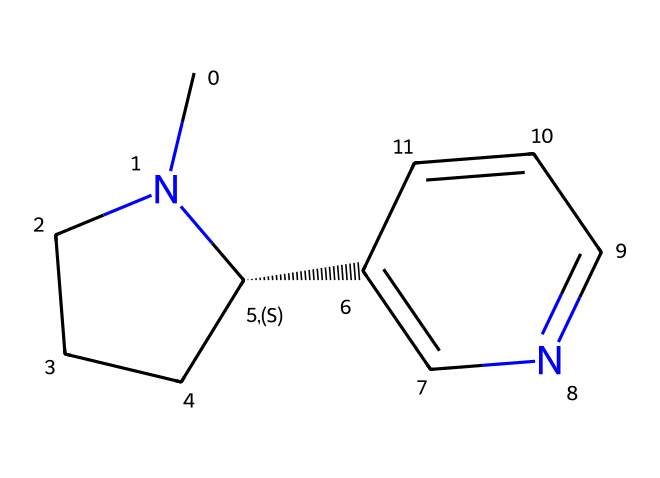What is the molecular formula of this chemical? By analyzing the structure represented by the SMILES notation, we can count the number of carbon (C), hydrogen (H), and nitrogen (N) atoms. The chemical has 10 carbon atoms, 14 hydrogen atoms, and 2 nitrogen atoms, resulting in a molecular formula of C10H14N2.
Answer: C10H14N2 How many rings are present in the structure? Observing the SMILES representation, we can identify two ring structures. One is a piperidine ring (six-membered) and the other is a pyridine ring (five-membered). Thus, there are 2 rings overall in the chemical structure.
Answer: 2 What is the primary functional group in this chemical? In this structure, the functional groups can often be identified by specific atom arrangements. The presence of nitrogen atoms indicates that it is an amine. Since there are two nitrogen atoms bonded in a ring structure, we classify it primarily as an amine.
Answer: amine Is this chemical considered a hazardous material? This chemical, being a component of tobacco and present in secondhand smoke, is categorized as a hazardous material due to its toxicological effects and potential for addiction. Hence, yes, it is considered hazardous.
Answer: yes What type of toxicity is this chemical associated with? Nicotine is primarily associated with neurotoxicity because it interacts with the nervous system and can lead to various adverse effects on neurological function. This classification is based on its known effects on the brain and nervous system.
Answer: neurotoxicity 